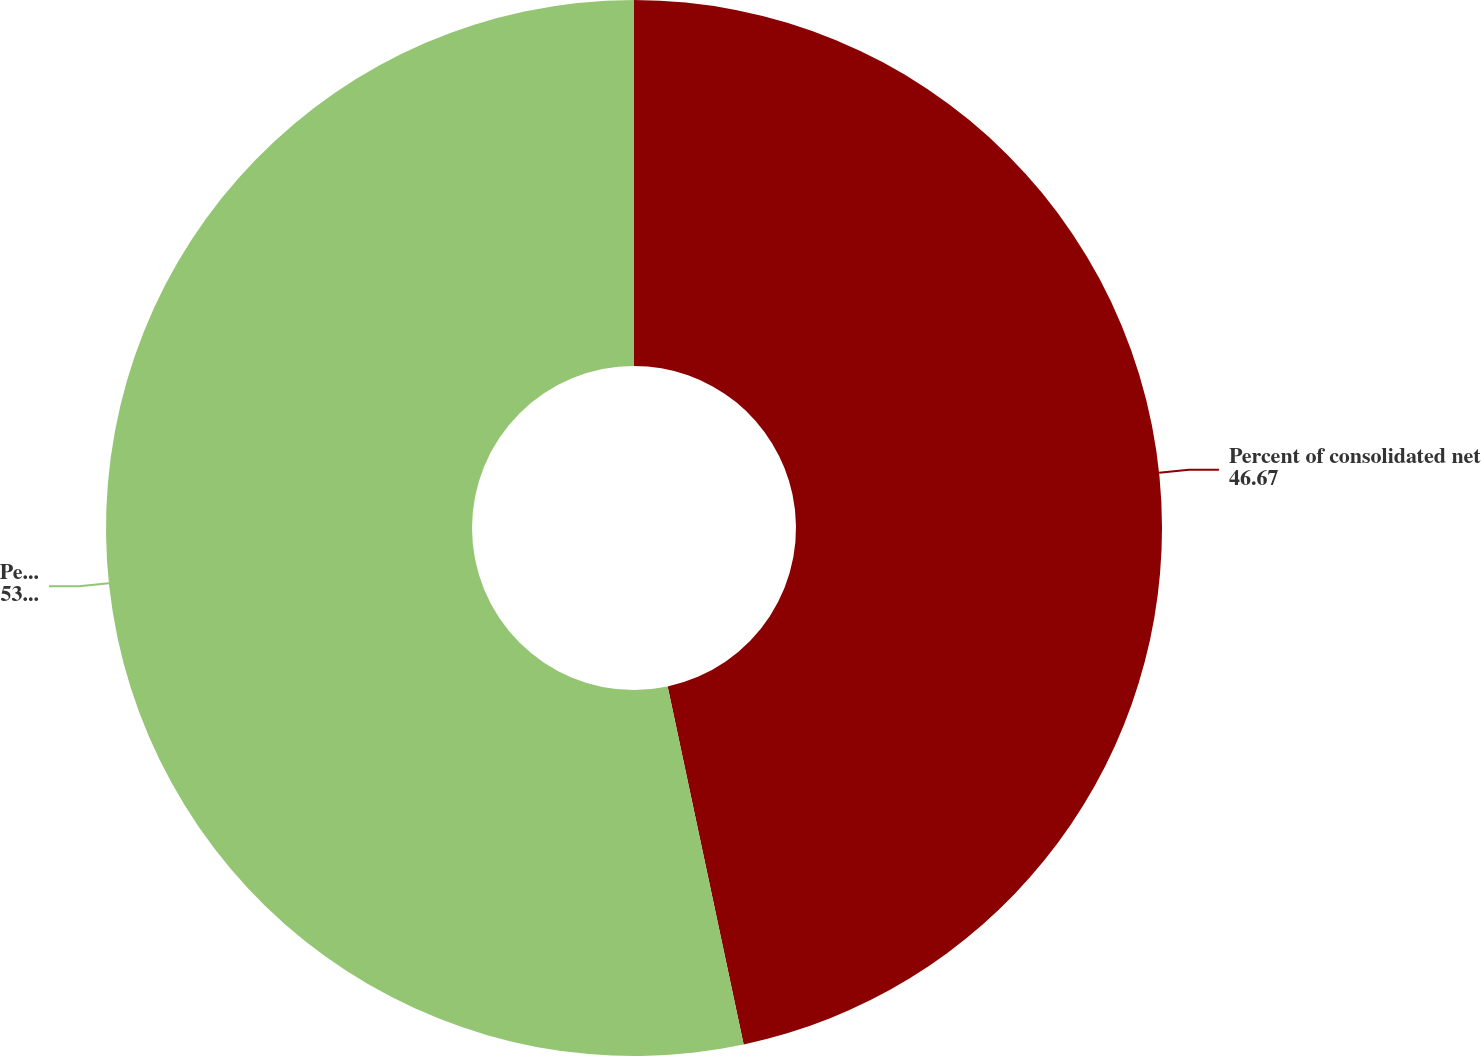<chart> <loc_0><loc_0><loc_500><loc_500><pie_chart><fcel>Percent of consolidated net<fcel>Percent of consolidated EBIT<nl><fcel>46.67%<fcel>53.33%<nl></chart> 